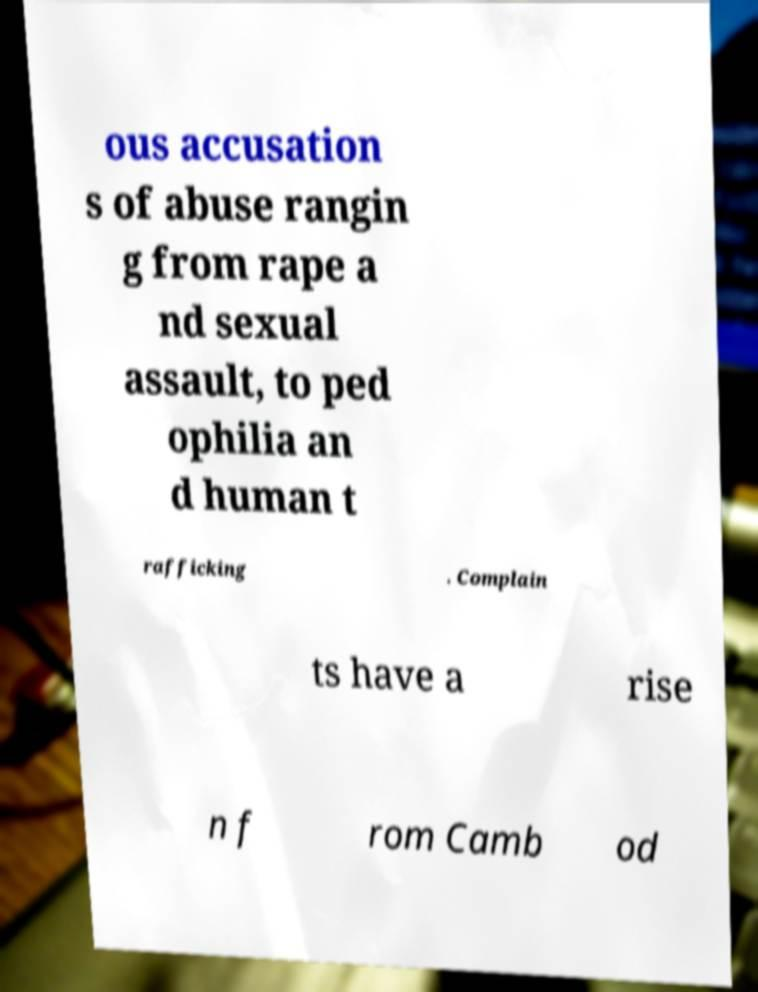Could you extract and type out the text from this image? ous accusation s of abuse rangin g from rape a nd sexual assault, to ped ophilia an d human t rafficking . Complain ts have a rise n f rom Camb od 